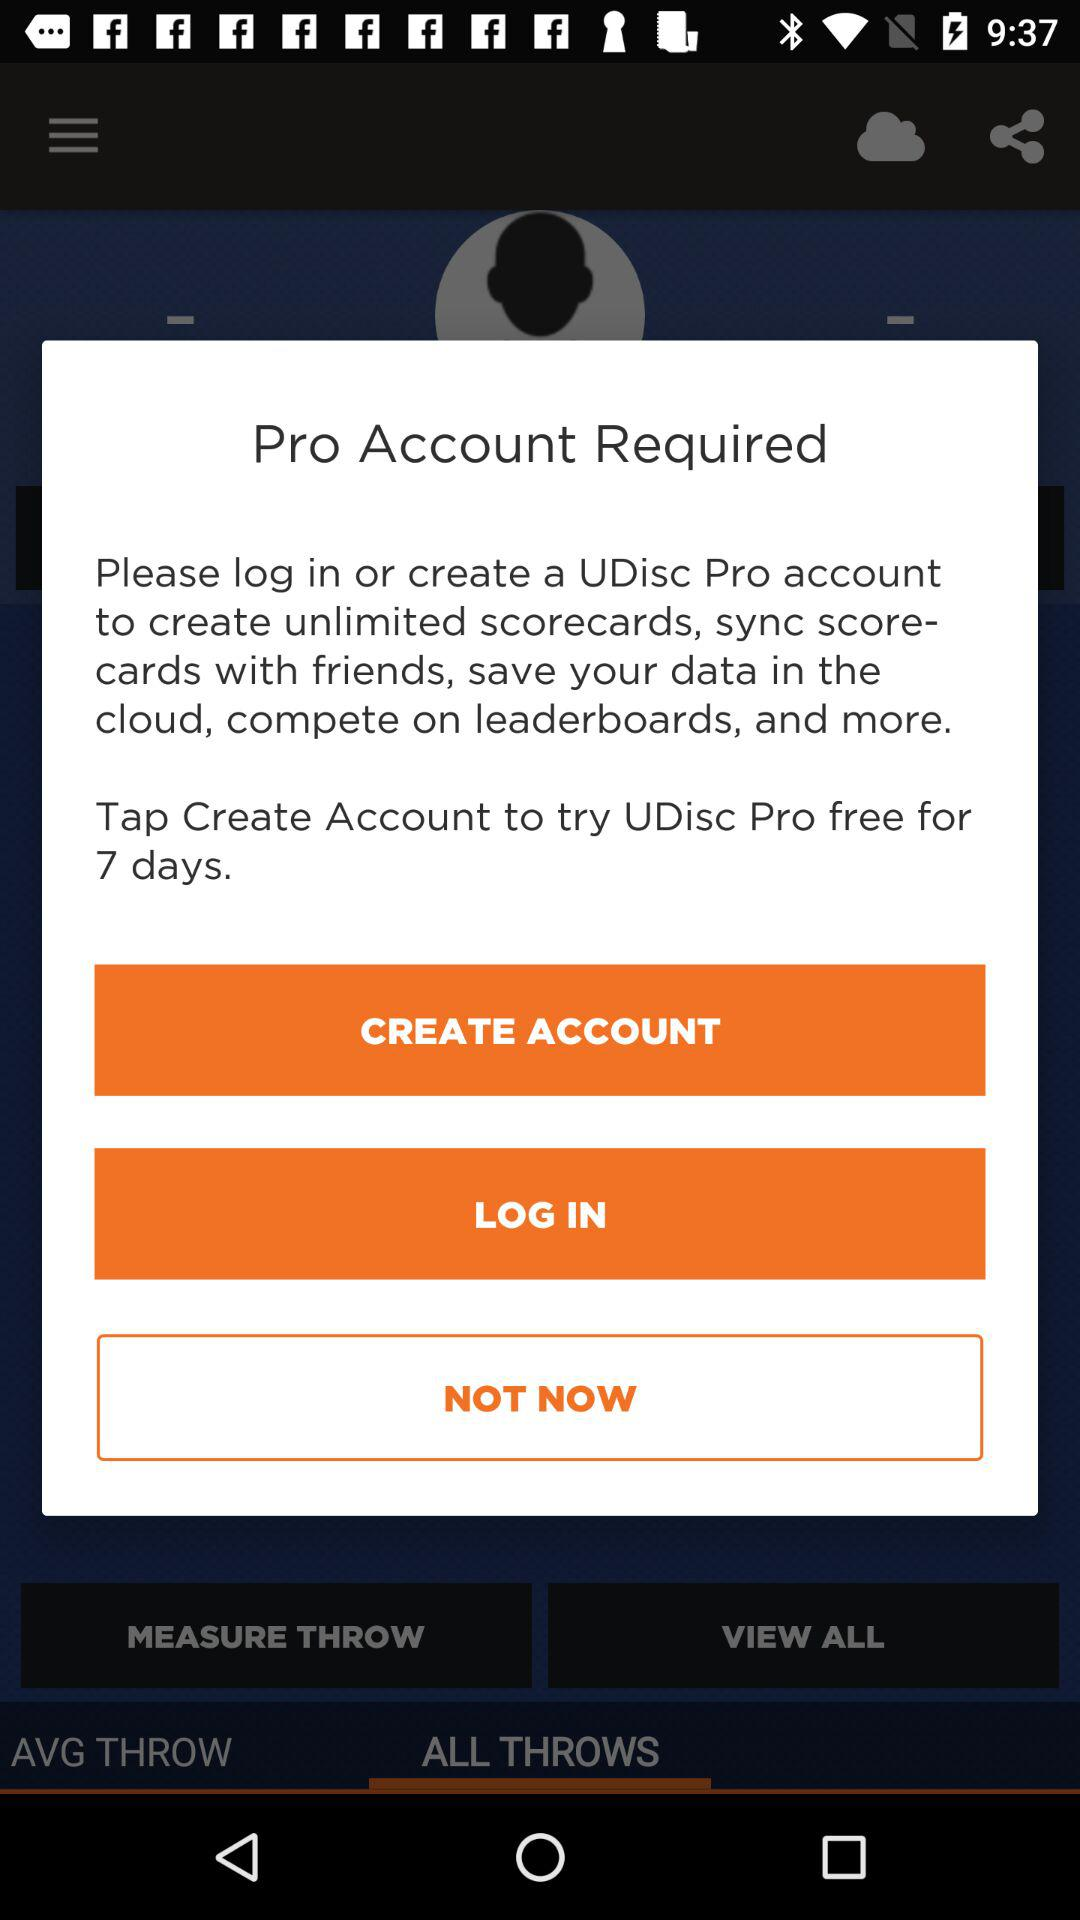Is a phone number required to create an account?
When the provided information is insufficient, respond with <no answer>. <no answer> 